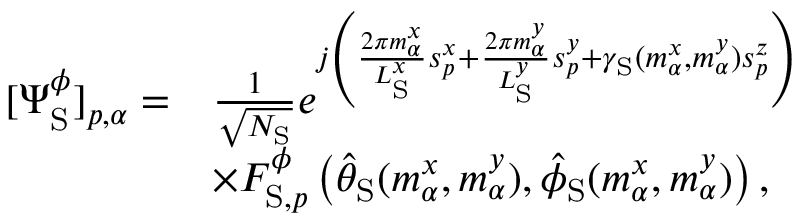<formula> <loc_0><loc_0><loc_500><loc_500>\begin{array} { r l } { [ \Psi _ { S } ^ { \phi } ] _ { p , \alpha } = } & { \frac { 1 } { \sqrt { N _ { S } } } e ^ { j \left ( \frac { 2 \pi m _ { \alpha } ^ { x } } { L _ { S } ^ { x } } s _ { p } ^ { x } + \frac { 2 \pi m _ { \alpha } ^ { y } } { L _ { S } ^ { y } } s _ { p } ^ { y } + \gamma _ { S } ( m _ { \alpha } ^ { x } , m _ { \alpha } ^ { y } ) s _ { p } ^ { z } \right ) } } \\ & { \times F _ { S , p } ^ { \phi } \left ( \hat { \theta } _ { S } ( m _ { \alpha } ^ { x } , m _ { \alpha } ^ { y } ) , \hat { \phi } _ { S } ( m _ { \alpha } ^ { x } , m _ { \alpha } ^ { y } ) \right ) , } \end{array}</formula> 